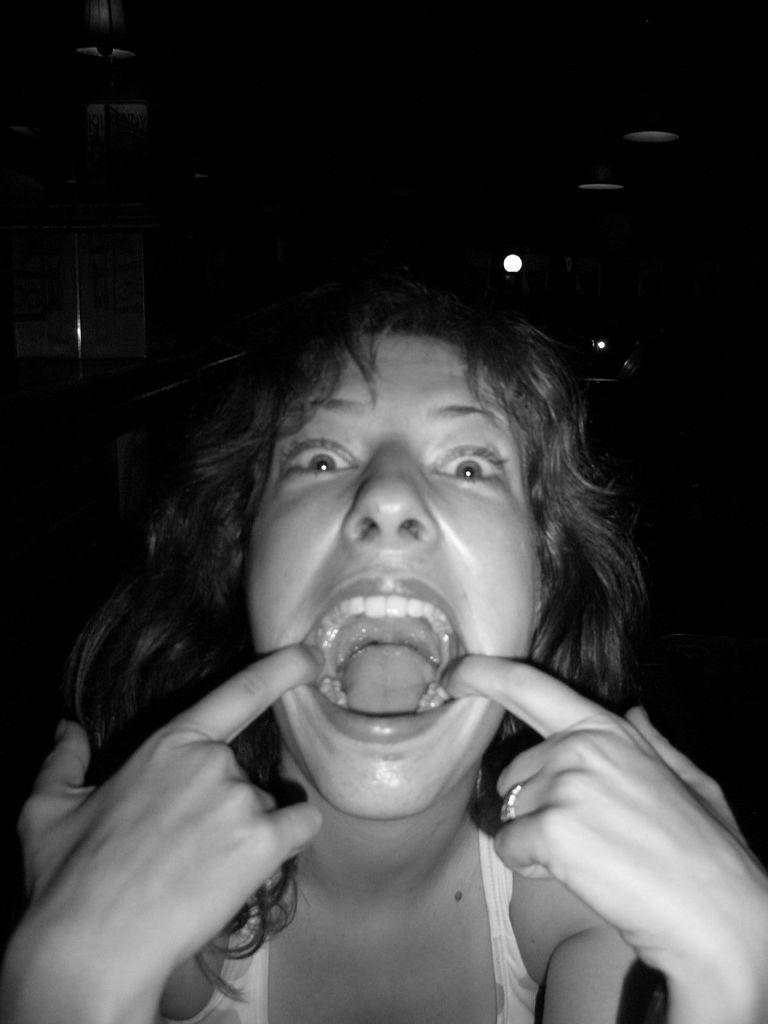Who is present in the image? There is a woman in the image. What is the color scheme of the image? The image is black and white. What can be seen at the top of the image? There are lights visible at the top of the image. What type of loaf is being baked in the image? There is no loaf or baking activity present in the image. What kind of copper material is used in the image? There is no copper material present in the image. 